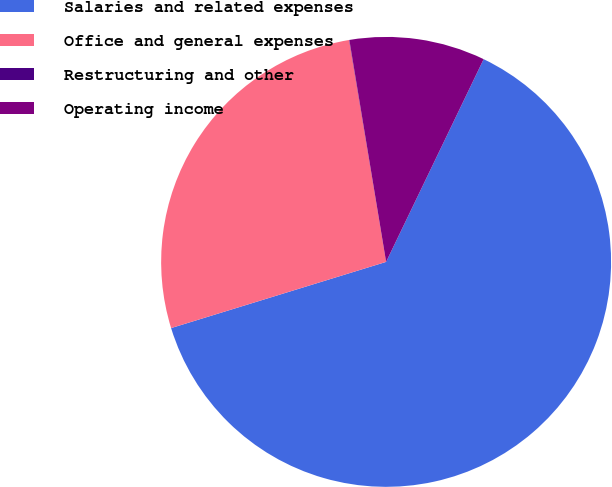<chart> <loc_0><loc_0><loc_500><loc_500><pie_chart><fcel>Salaries and related expenses<fcel>Office and general expenses<fcel>Restructuring and other<fcel>Operating income<nl><fcel>63.11%<fcel>27.12%<fcel>0.02%<fcel>9.75%<nl></chart> 